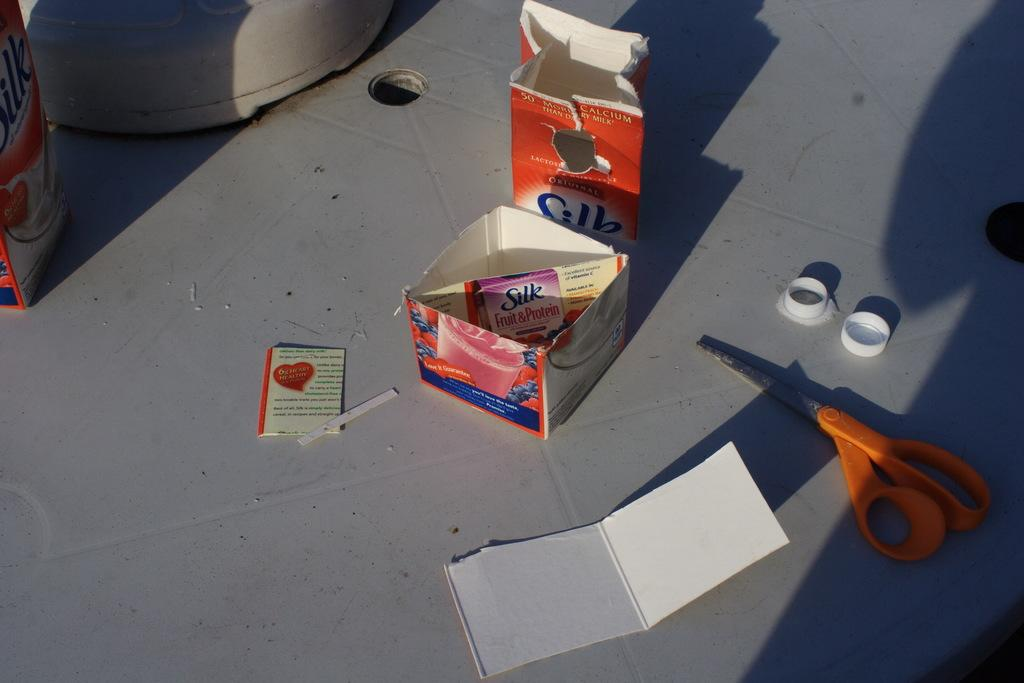<image>
Present a compact description of the photo's key features. An opened pack of Silk Fruit & Protein with a pair of scissors beside it. 